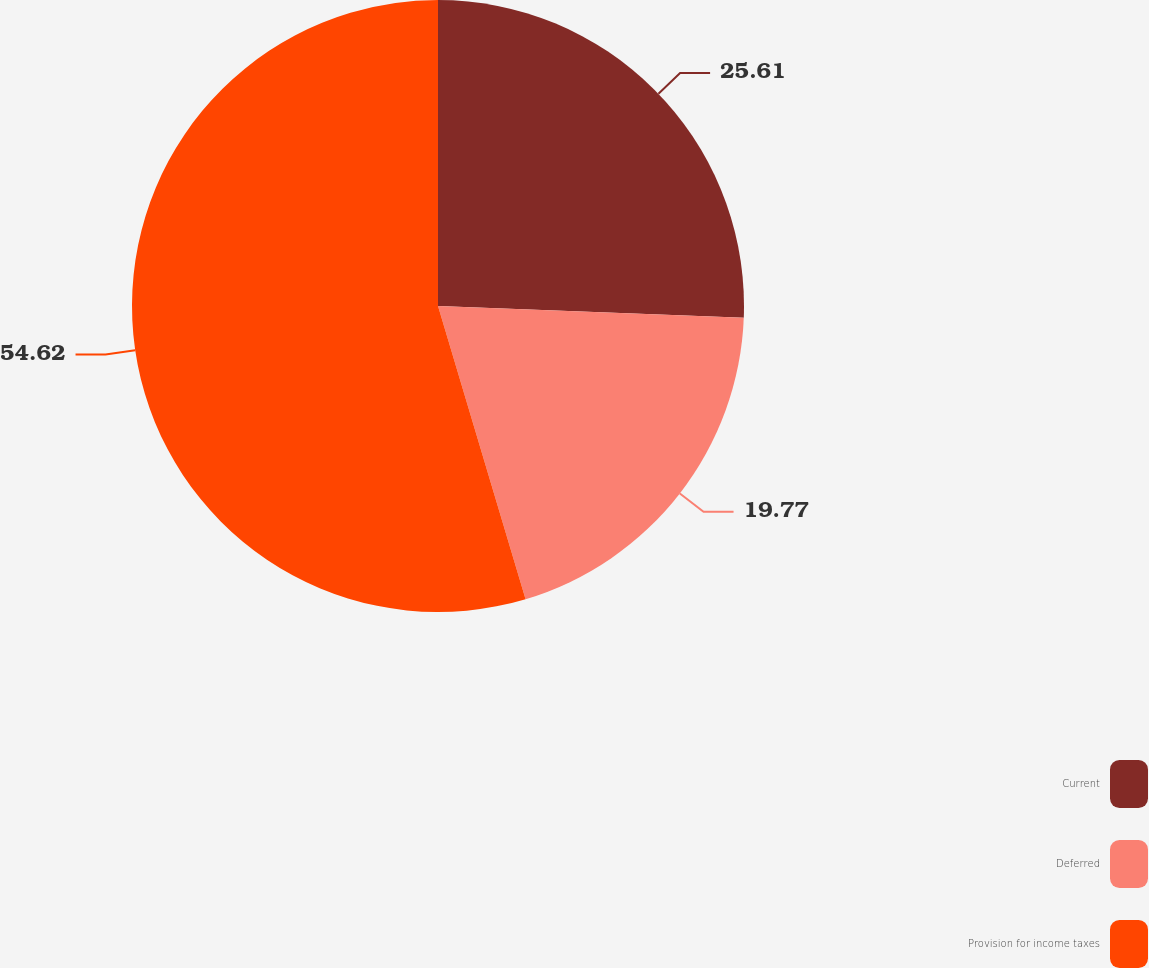Convert chart. <chart><loc_0><loc_0><loc_500><loc_500><pie_chart><fcel>Current<fcel>Deferred<fcel>Provision for income taxes<nl><fcel>25.61%<fcel>19.77%<fcel>54.62%<nl></chart> 